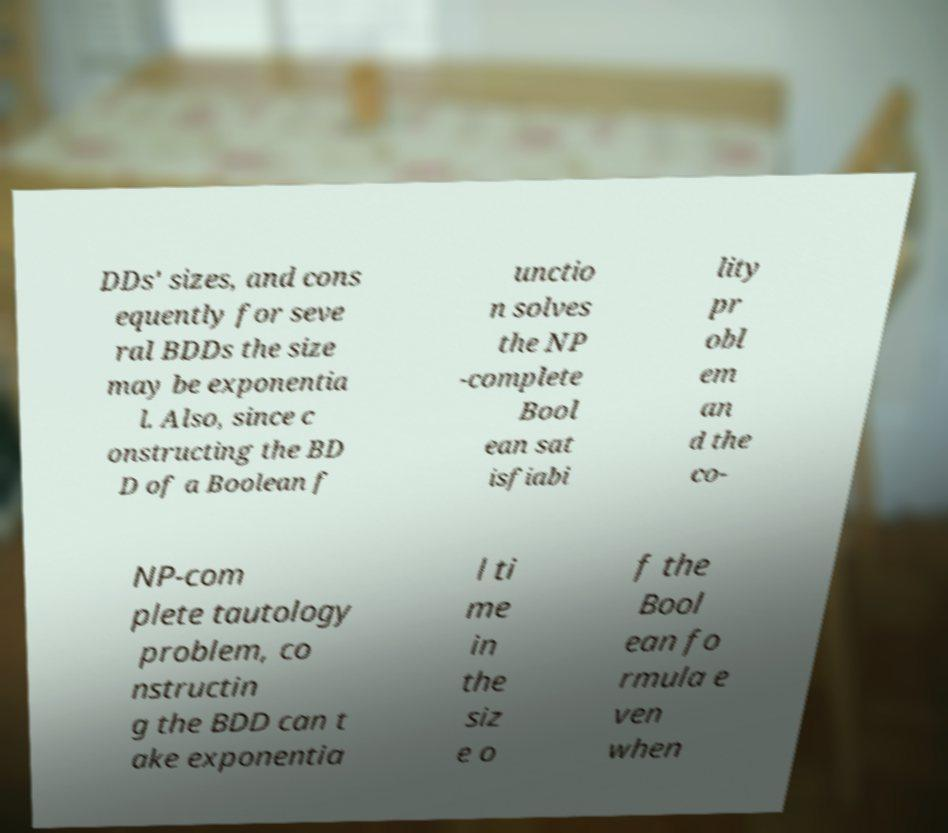Please read and relay the text visible in this image. What does it say? DDs' sizes, and cons equently for seve ral BDDs the size may be exponentia l. Also, since c onstructing the BD D of a Boolean f unctio n solves the NP -complete Bool ean sat isfiabi lity pr obl em an d the co- NP-com plete tautology problem, co nstructin g the BDD can t ake exponentia l ti me in the siz e o f the Bool ean fo rmula e ven when 